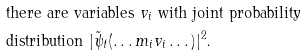<formula> <loc_0><loc_0><loc_500><loc_500>& \text {there are variables $v_{i}$ with joint probability} \\ & \text {distribution $|\tilde{\psi}_{t}(\dots m_{i}v_{i} \dots)|^{2}$.}</formula> 